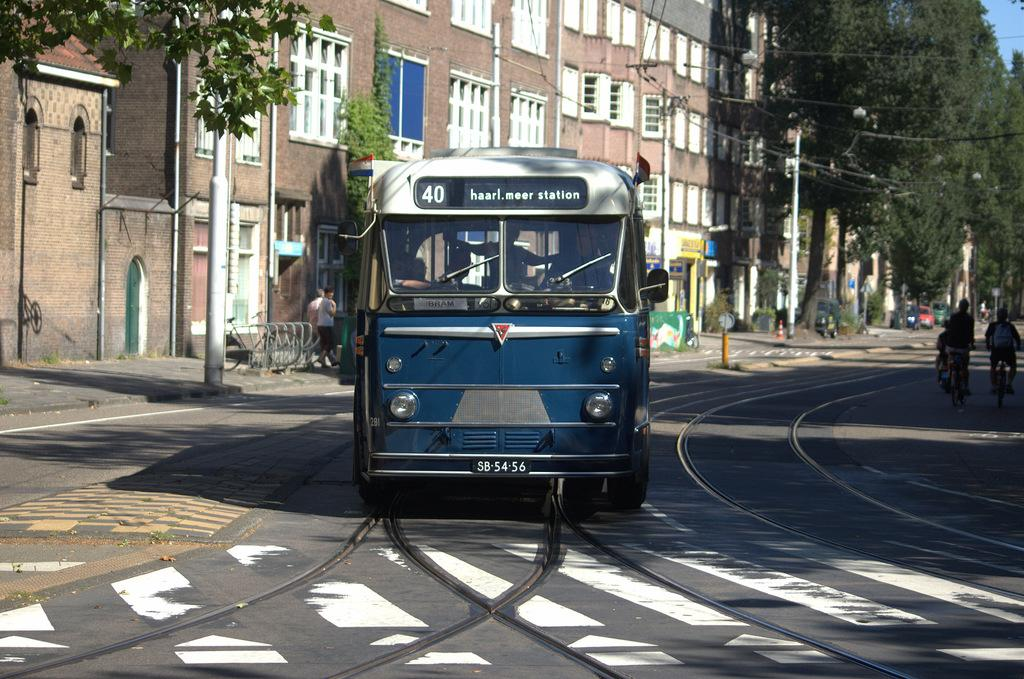What is the main subject in the center of the image? There is a bus in the center of the image. Where is the bus located? The bus is on the road. What are some other vehicles or modes of transportation in the image? There are people riding bicycles. What can be seen in the background of the image? There are buildings, trees, poles, and wires visible in the background. What song is the bus driver singing in the image? There is no indication in the image that the bus driver is singing a song. 